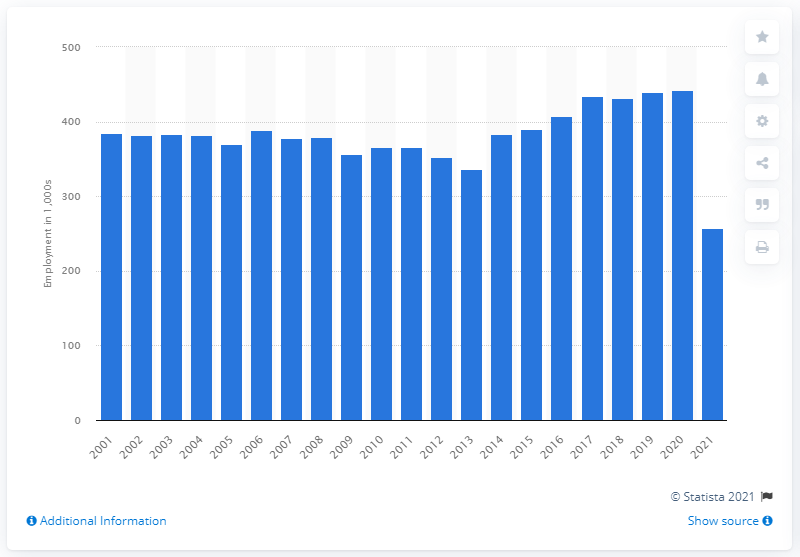Outline some significant characteristics in this image. In the previous year in the United States, the motion picture and sound recording industry employed approximately 441.9 people. 